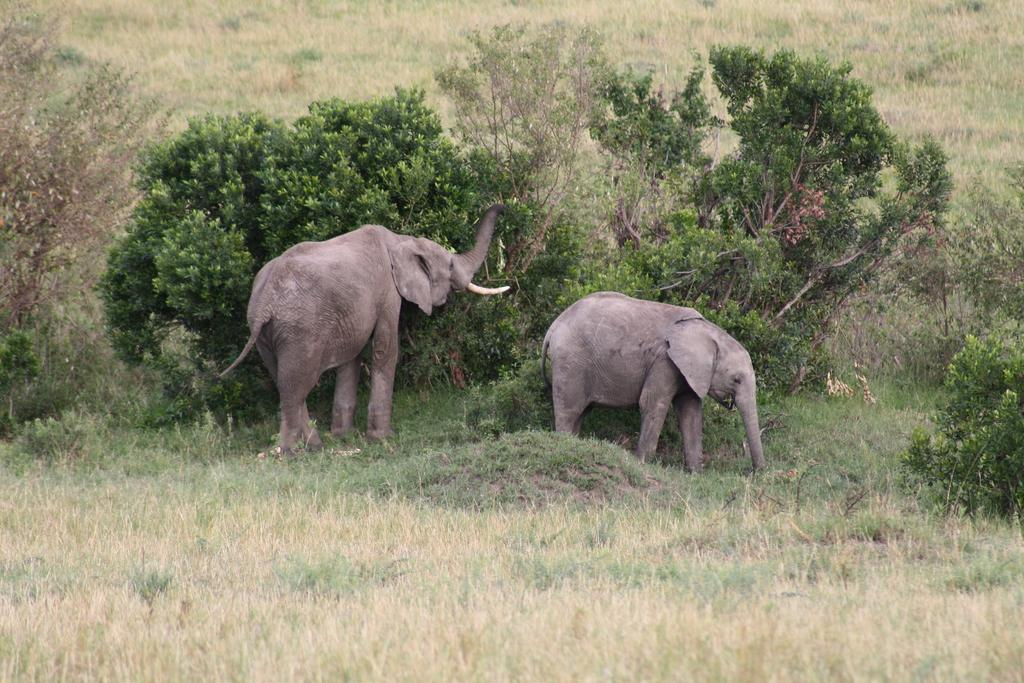How many elephants are in the image? There are two elephants in the image. What is the terrain where the elephants are standing? The elephants are standing on grassland. What type of vegetation can be seen in the image? There are plants and trees in the image. What flavor of scissors can be seen in the image? There are no scissors present in the image, so it is not possible to determine their flavor. 